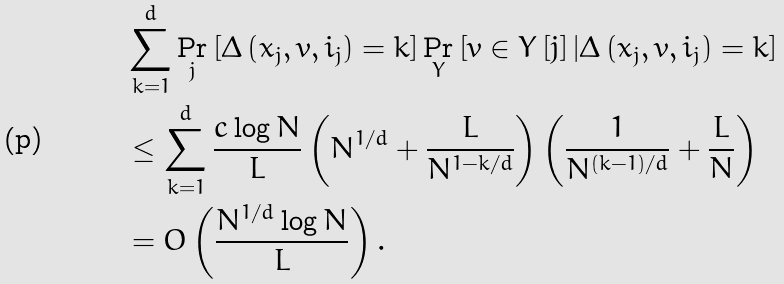Convert formula to latex. <formula><loc_0><loc_0><loc_500><loc_500>& \sum _ { k = 1 } ^ { d } \Pr _ { j } \left [ \Delta \left ( x _ { j } , v , i _ { j } \right ) = k \right ] \Pr _ { Y } \left [ v \in Y \left [ j \right ] | \Delta \left ( x _ { j } , v , i _ { j } \right ) = k \right ] \\ & \leq \sum _ { k = 1 } ^ { d } \frac { c \log N } { L } \left ( N ^ { 1 / d } + \frac { L } { N ^ { 1 - k / d } } \right ) \left ( \frac { 1 } { N ^ { \left ( k - 1 \right ) / d } } + \frac { L } { N } \right ) \\ & = O \left ( \frac { N ^ { 1 / d } \log N } { L } \right ) .</formula> 